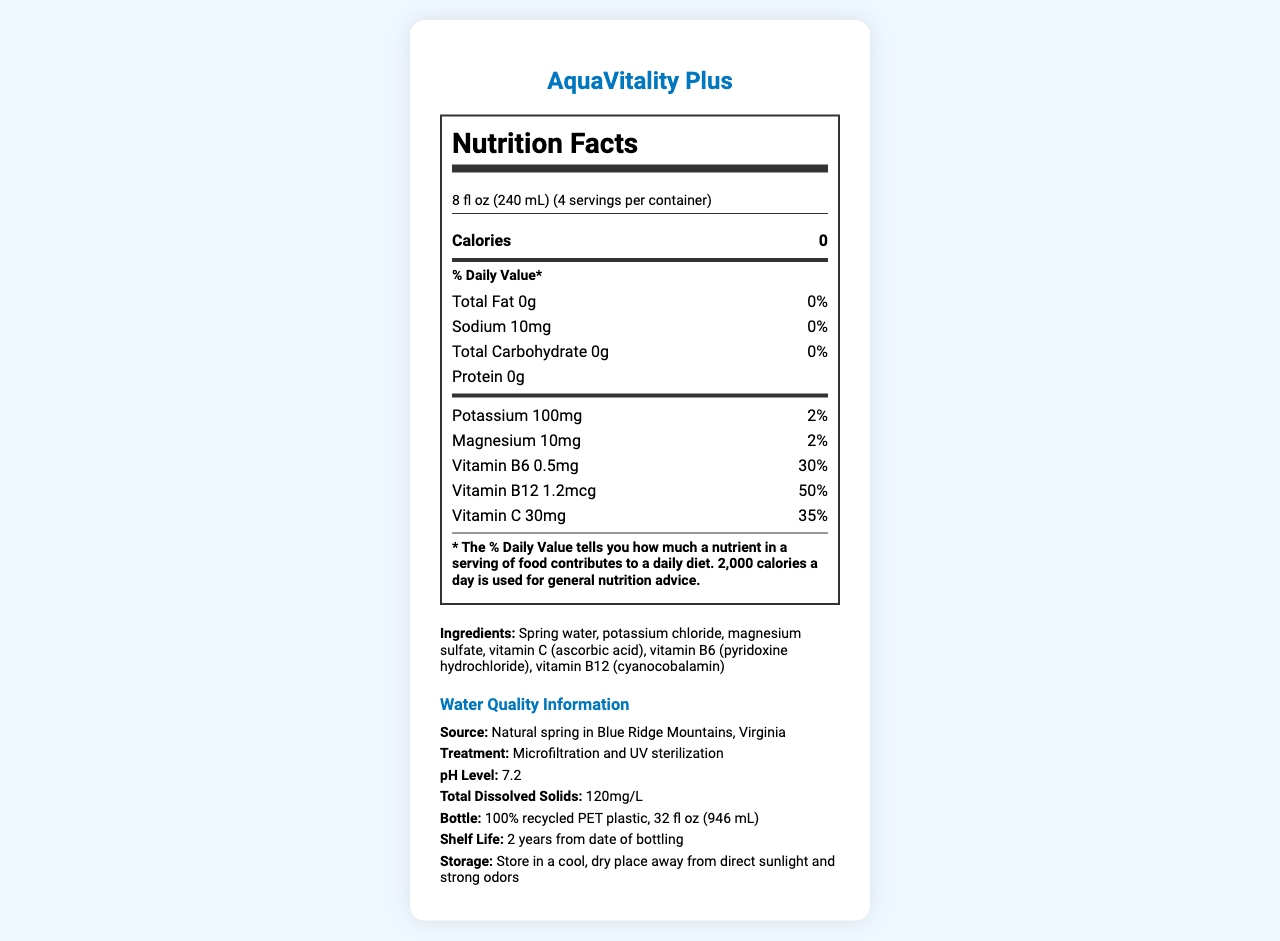what is the serving size of AquaVitality Plus? The serving size is mentioned at the top of the Nutrition Facts section: "8 fl oz (240 mL)".
Answer: 8 fl oz (240 mL) how many servings are in one container? The servings per container are given as "4" next to the serving size.
Answer: 4 how many calories are in each serving? The number of calories per serving is listed as "0" under the "Calories" section.
Answer: 0 how much sodium is in each serving? Sodium content per serving is listed as "10mg" in the nutrient facts.
Answer: 10mg what are the added electrolytes and their amounts in AquaVitality Plus? The added electrolytes and their amounts are listed in the document: Potassium (100mg) and Magnesium (10mg).
Answer: Potassium: 100mg, Magnesium: 10mg which vitamin has the highest daily value percentage? A. Vitamin B6 B. Vitamin B12 C. Vitamin C Vitamin B12 has the highest daily value percentage at 50%, followed by Vitamin C at 35% and Vitamin B6 at 30%.
Answer: B which ingredient is not a vitamin or mineral? A. Potassium chloride B. Vitamin C C. Vitamin B12 Potassium chloride is listed as an ingredient but is not classified as a vitamin or mineral.
Answer: A is the water pH value acidic, neutral, or basic? The pH level of the water is given as 7.2, which is close to neutral (7.0).
Answer: Neutral does AquaVitality Plus comply with FDA regulations? The document states that the product meets or exceeds all FDA regulations for bottled water.
Answer: Yes how often is quality testing performed? Quality testing frequency is mentioned as "Hourly microbiological testing, daily chemical analysis".
Answer: Hourly microbiological testing, daily chemical analysis is AquaVitality Plus packaged in recycled plastic? The bottle type is described as "100% recycled PET plastic".
Answer: Yes what is the pH level of the water? The pH level is clearly stated in the water quality information section.
Answer: 7.2 describe the main idea of the document. This summary covers all main sections of the document such as nutrition information, ingredient list, quality details, and compliance.
Answer: The document provides comprehensive details about AquaVitality Plus bottled water, including its nutrition facts, added vitamins and electrolytes, ingredients, water source, treatment process, pH level, mineral content, regulatory compliance, shelf life, and storage instructions. which mineral has the highest concentration in the water's mineral content? The mineral content section lists 15mg/L for Calcium, which is the highest concentration among the minerals listed.
Answer: Calcium can the exact location of the natural spring in the Blue Ridge Mountains be determined from the document? The document specifies the location as the Blue Ridge Mountains, Virginia, but does not provide an exact location.
Answer: No what is the total carbohydrate content per serving? The total carbohydrate content per serving is listed as "0g" in the nutrient facts section.
Answer: 0g 